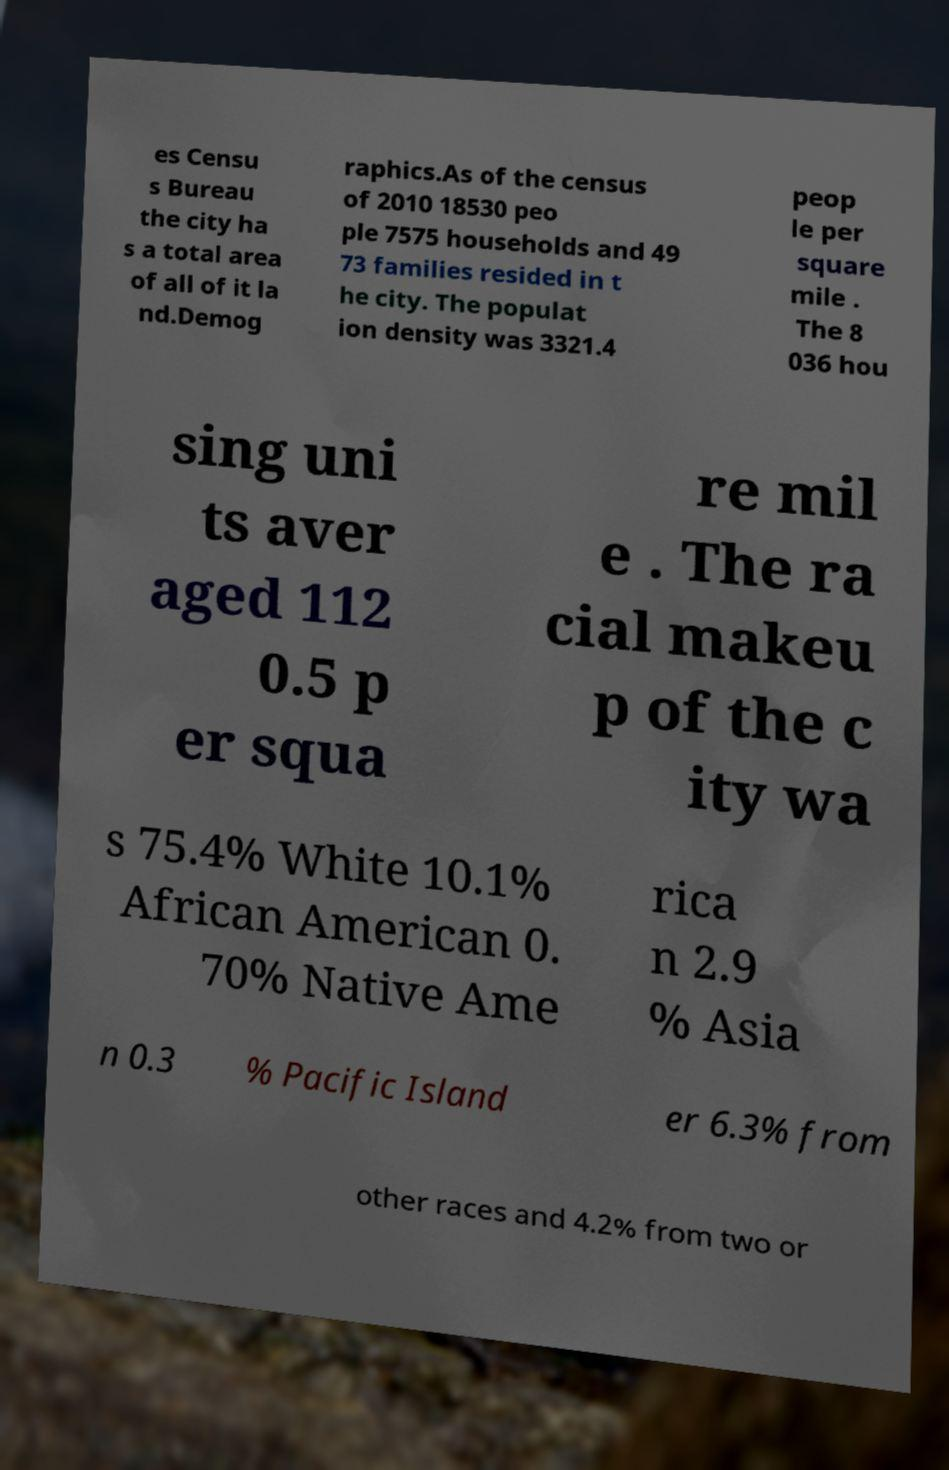Please read and relay the text visible in this image. What does it say? es Censu s Bureau the city ha s a total area of all of it la nd.Demog raphics.As of the census of 2010 18530 peo ple 7575 households and 49 73 families resided in t he city. The populat ion density was 3321.4 peop le per square mile . The 8 036 hou sing uni ts aver aged 112 0.5 p er squa re mil e . The ra cial makeu p of the c ity wa s 75.4% White 10.1% African American 0. 70% Native Ame rica n 2.9 % Asia n 0.3 % Pacific Island er 6.3% from other races and 4.2% from two or 